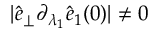<formula> <loc_0><loc_0><loc_500><loc_500>| \hat { e } _ { \perp } \partial _ { \lambda _ { 1 } } \hat { e } _ { 1 } ( 0 ) | \neq 0</formula> 